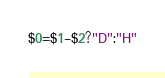Convert code to text. <code><loc_0><loc_0><loc_500><loc_500><_Awk_>$0=$1-$2?"D":"H"</code> 